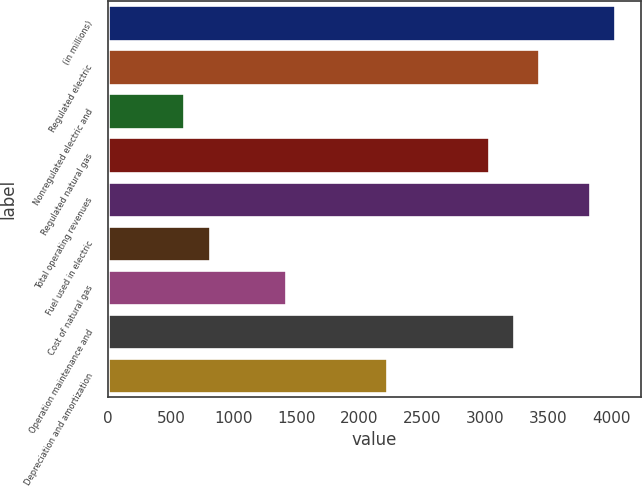<chart> <loc_0><loc_0><loc_500><loc_500><bar_chart><fcel>(in millions)<fcel>Regulated electric<fcel>Nonregulated electric and<fcel>Regulated natural gas<fcel>Total operating revenues<fcel>Fuel used in electric<fcel>Cost of natural gas<fcel>Operation maintenance and<fcel>Depreciation and amortization<nl><fcel>4033<fcel>3428.2<fcel>605.8<fcel>3025<fcel>3831.4<fcel>807.4<fcel>1412.2<fcel>3226.6<fcel>2218.6<nl></chart> 